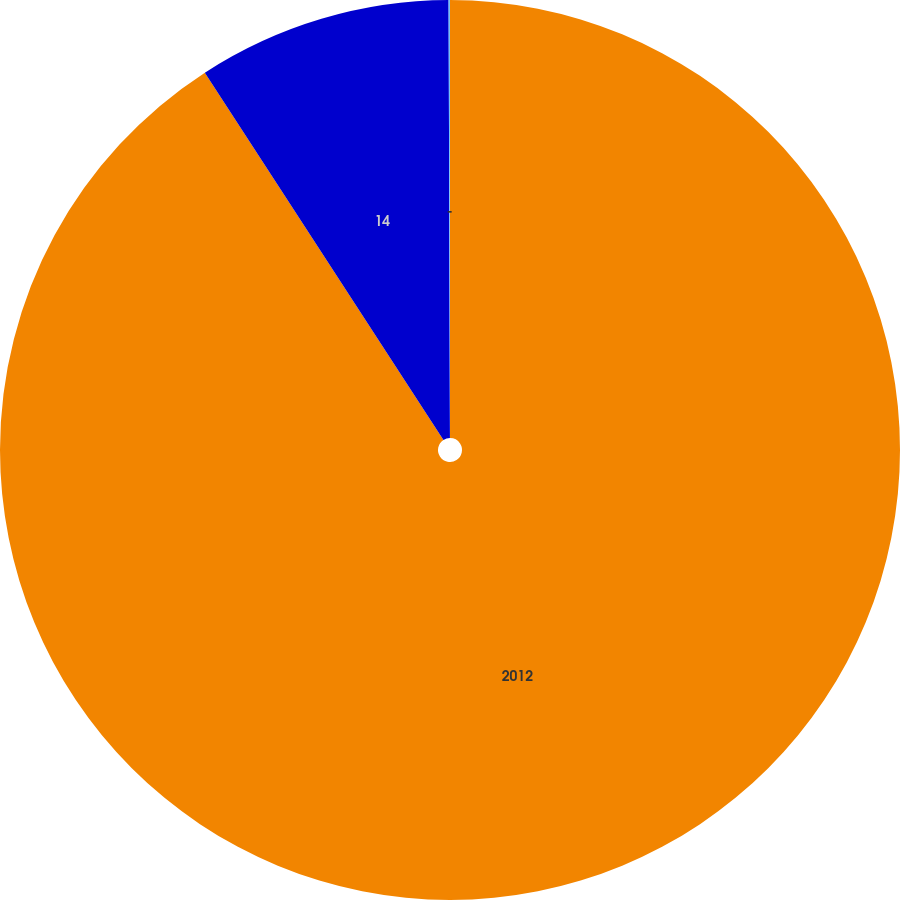Convert chart to OTSL. <chart><loc_0><loc_0><loc_500><loc_500><pie_chart><fcel>2012<fcel>14<fcel>-<nl><fcel>90.83%<fcel>9.12%<fcel>0.05%<nl></chart> 